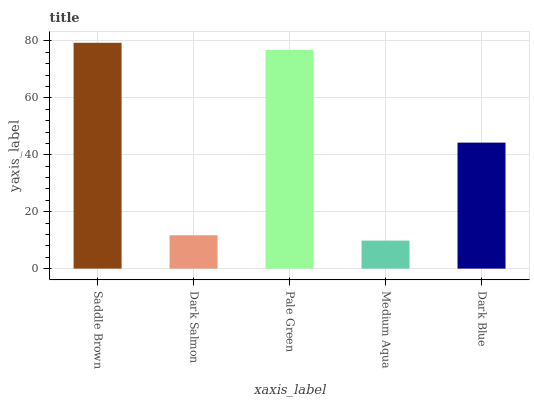Is Medium Aqua the minimum?
Answer yes or no. Yes. Is Saddle Brown the maximum?
Answer yes or no. Yes. Is Dark Salmon the minimum?
Answer yes or no. No. Is Dark Salmon the maximum?
Answer yes or no. No. Is Saddle Brown greater than Dark Salmon?
Answer yes or no. Yes. Is Dark Salmon less than Saddle Brown?
Answer yes or no. Yes. Is Dark Salmon greater than Saddle Brown?
Answer yes or no. No. Is Saddle Brown less than Dark Salmon?
Answer yes or no. No. Is Dark Blue the high median?
Answer yes or no. Yes. Is Dark Blue the low median?
Answer yes or no. Yes. Is Dark Salmon the high median?
Answer yes or no. No. Is Medium Aqua the low median?
Answer yes or no. No. 